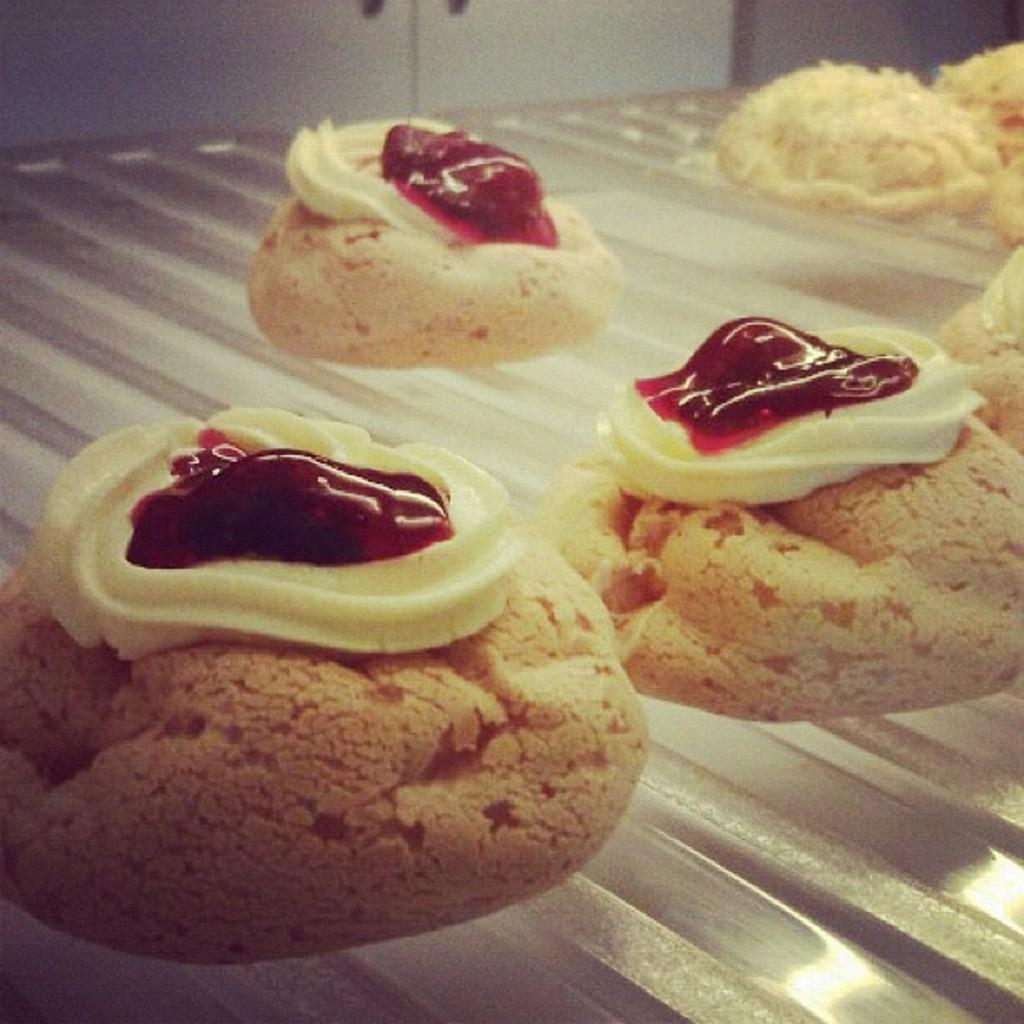What is the main subject of the image? The main subject of the image is donuts. Where are the donuts located in the image? The donuts are in the center of the image. What advice does the donut give to the person in the image? There is no person present in the image, and donuts cannot give advice. 